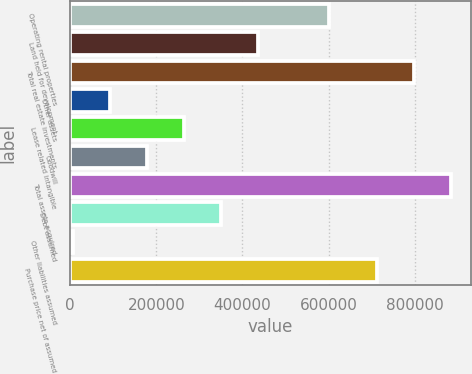<chart> <loc_0><loc_0><loc_500><loc_500><bar_chart><fcel>Operating rental properties<fcel>Land held for development<fcel>Total real estate investments<fcel>Other assets<fcel>Lease related intangible<fcel>Goodwill<fcel>Total assets acquired<fcel>Debt assumed<fcel>Other liabilities assumed<fcel>Purchase price net of assumed<nl><fcel>602011<fcel>436694<fcel>799375<fcel>92001.9<fcel>264348<fcel>178175<fcel>885548<fcel>350521<fcel>5829<fcel>713202<nl></chart> 